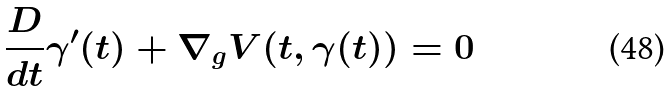Convert formula to latex. <formula><loc_0><loc_0><loc_500><loc_500>\frac { D } { d t } \gamma ^ { \prime } ( t ) + \nabla _ { g } V ( t , \gamma ( t ) ) = 0</formula> 